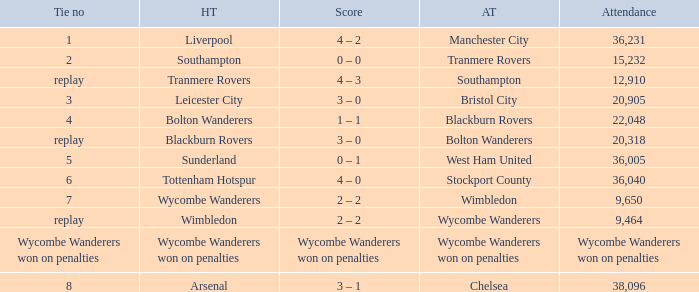What was the score for the match where the home team was Leicester City? 3 – 0. Could you parse the entire table? {'header': ['Tie no', 'HT', 'Score', 'AT', 'Attendance'], 'rows': [['1', 'Liverpool', '4 – 2', 'Manchester City', '36,231'], ['2', 'Southampton', '0 – 0', 'Tranmere Rovers', '15,232'], ['replay', 'Tranmere Rovers', '4 – 3', 'Southampton', '12,910'], ['3', 'Leicester City', '3 – 0', 'Bristol City', '20,905'], ['4', 'Bolton Wanderers', '1 – 1', 'Blackburn Rovers', '22,048'], ['replay', 'Blackburn Rovers', '3 – 0', 'Bolton Wanderers', '20,318'], ['5', 'Sunderland', '0 – 1', 'West Ham United', '36,005'], ['6', 'Tottenham Hotspur', '4 – 0', 'Stockport County', '36,040'], ['7', 'Wycombe Wanderers', '2 – 2', 'Wimbledon', '9,650'], ['replay', 'Wimbledon', '2 – 2', 'Wycombe Wanderers', '9,464'], ['Wycombe Wanderers won on penalties', 'Wycombe Wanderers won on penalties', 'Wycombe Wanderers won on penalties', 'Wycombe Wanderers won on penalties', 'Wycombe Wanderers won on penalties'], ['8', 'Arsenal', '3 – 1', 'Chelsea', '38,096']]} 